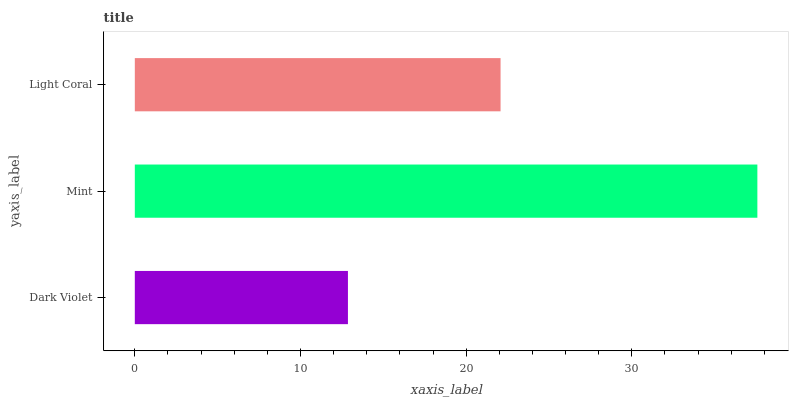Is Dark Violet the minimum?
Answer yes or no. Yes. Is Mint the maximum?
Answer yes or no. Yes. Is Light Coral the minimum?
Answer yes or no. No. Is Light Coral the maximum?
Answer yes or no. No. Is Mint greater than Light Coral?
Answer yes or no. Yes. Is Light Coral less than Mint?
Answer yes or no. Yes. Is Light Coral greater than Mint?
Answer yes or no. No. Is Mint less than Light Coral?
Answer yes or no. No. Is Light Coral the high median?
Answer yes or no. Yes. Is Light Coral the low median?
Answer yes or no. Yes. Is Dark Violet the high median?
Answer yes or no. No. Is Dark Violet the low median?
Answer yes or no. No. 